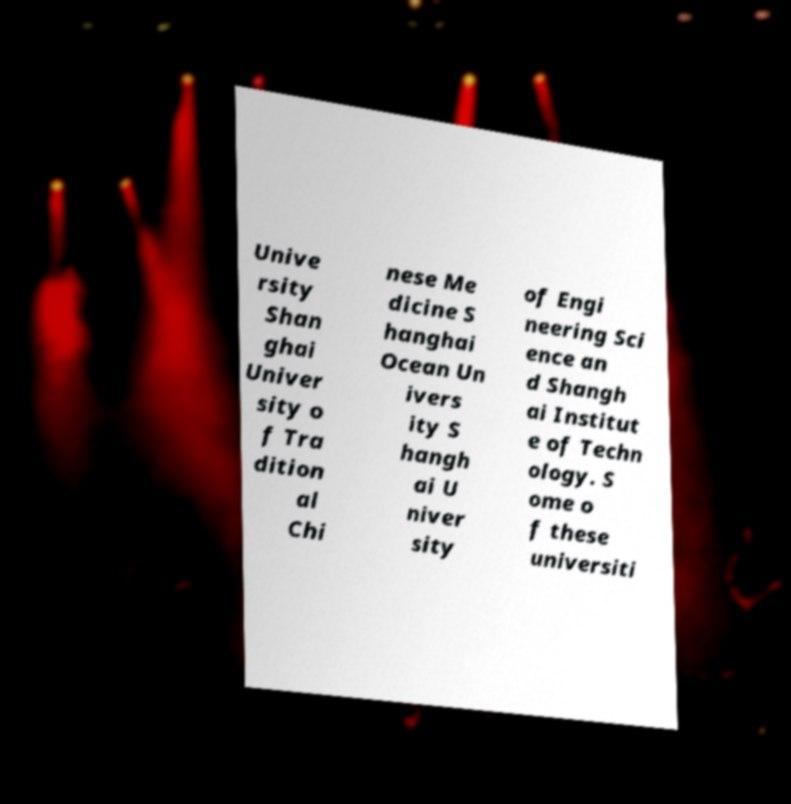There's text embedded in this image that I need extracted. Can you transcribe it verbatim? Unive rsity Shan ghai Univer sity o f Tra dition al Chi nese Me dicine S hanghai Ocean Un ivers ity S hangh ai U niver sity of Engi neering Sci ence an d Shangh ai Institut e of Techn ology. S ome o f these universiti 